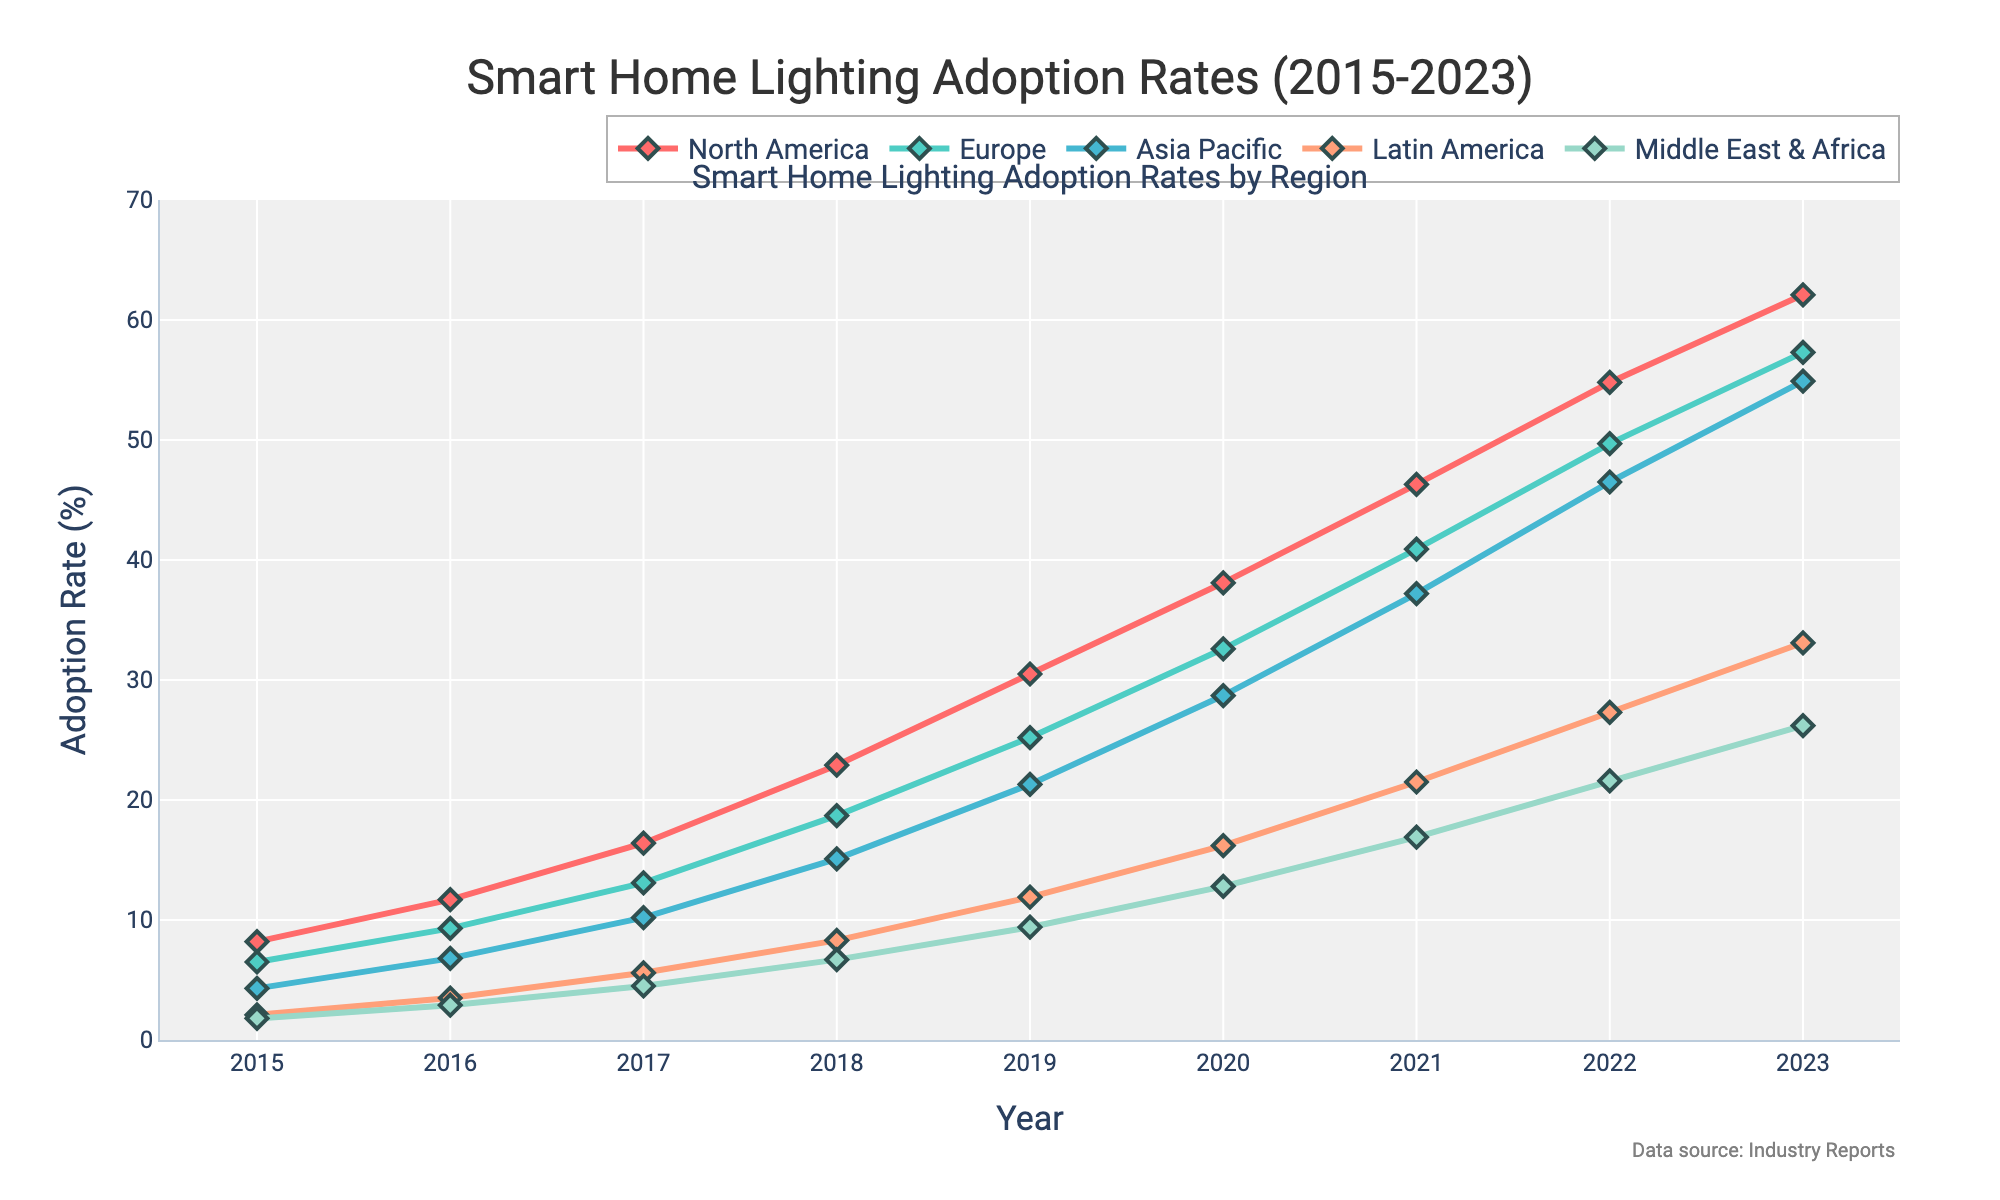What is the adoption rate of Smart Home Lighting Systems in North America in 2023? In the figure, look at the adoption rate for North America in the year 2023. The data shows the value as 62.1%.
Answer: 62.1% Which region had the lowest adoption rate in 2015, and what was it? Review the adoption rates of all regions for the year 2015; the Middle East & Africa had the lowest rate at 1.8%.
Answer: Middle East & Africa, 1.8% How much did the adoption rate in Europe increase from 2015 to 2023? Subtract the adoption rate of Europe in 2015 (6.5%) from that in 2023 (57.3%). The increase is 57.3% - 6.5% = 50.8%.
Answer: 50.8% In which year did the Asia Pacific region surpass the 20% adoption rate? Examine the adoption rates for Asia Pacific across the years and identify when it first exceeded 20%. In 2019, it reached 21.3%.
Answer: 2019 Which region had the highest growth rate between 2018 and 2020? Calculate the growth rates for each region from 2018 to 2020 by finding the differences in adoption rates over these two years. North America: 38.1 - 22.9 = 15.2, Europe: 32.6 - 18.7 = 13.9, Asia Pacific: 28.7 - 15.1 = 13.6, Latin America: 16.2 - 8.3 = 7.9, Middle East & Africa: 12.8 - 6.7 = 6.1. North America had the highest growth rate of 15.2%.
Answer: North America By how much did the adoption rate in Latin America change from 2016 to 2019? Subtrack the adoption rate of Latin America in 2016 (3.5%) from that in 2019 (11.9%). The increase is 11.9% - 3.5% = 8.4%.
Answer: 8.4% What was the rate change in the Middle East & Africa region from 2021 to 2023? Subtract the 2021 rate (16.9%) from the 2023 rate (26.2%). The change equals 26.2% - 16.9% = 9.3%.
Answer: 9.3% Which region showed the second highest adoption rate in 2022? Examine the adoption rates in 2022 and identify the second highest value, which belongs to Europe with 49.7%.
Answer: Europe Compare the adoption rates of North America and Europe in 2020. Which region had a higher rate and by how much? Compare the values for North America (38.1%) and Europe (32.6%) in 2020. North America is higher by 38.1% - 32.6% = 5.5%.
Answer: North America, 5.5% What visual attributes can help identify the trend of adoption rates in Asia Pacific? Observe the line representing Asia Pacific, which is colored in light blue with diamond markers. The line consistently rises from 2015 to 2023, indicating an upward trend.
Answer: Increasing trend, light blue, diamond markers 